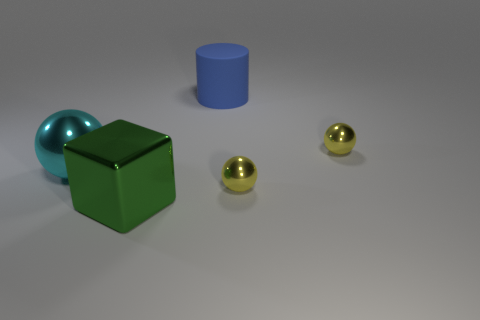Are there more large red matte balls than big blocks?
Ensure brevity in your answer.  No. There is a sphere left of the big rubber thing; what color is it?
Offer a very short reply. Cyan. Is the number of yellow spheres that are behind the cylinder greater than the number of yellow blocks?
Offer a terse response. No. Is the green thing made of the same material as the big blue object?
Your response must be concise. No. What number of other objects are there of the same shape as the blue rubber thing?
Your answer should be very brief. 0. Is there any other thing that is the same material as the cyan ball?
Your response must be concise. Yes. There is a small object on the left side of the tiny yellow shiny object that is behind the big thing left of the large green cube; what is its color?
Keep it short and to the point. Yellow. There is a tiny metal thing that is behind the cyan metallic thing; is it the same shape as the green metallic thing?
Your response must be concise. No. What number of small yellow objects are there?
Make the answer very short. 2. How many cyan shiny things are the same size as the rubber cylinder?
Provide a short and direct response. 1. 